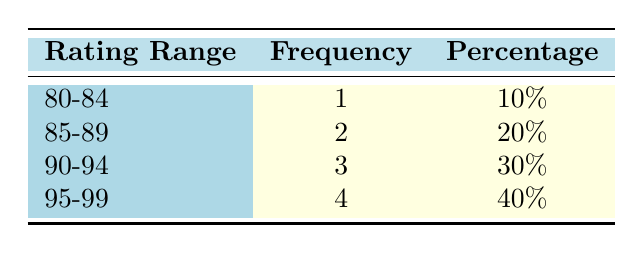What is the frequency of films with an audience rating between 90 and 94? The range of 90 to 94 appears in the table, where the frequency for this rating range is stated as 3.
Answer: 3 What percentage of films received an audience rating of 95 or above? To find this percentage, we look at the rating range of 95-99, which shows a frequency of 4 out of a total of 10 films. Therefore, the percentage is calculated as (4/10) * 100 = 40%.
Answer: 40% How many films have an audience rating lower than 85? According to the table, only the rating range of 80-84 has a frequency of 1, indicating that there is one film with a rating lower than 85.
Answer: 1 Is the statement "More than half of the films received audience ratings below 90" true or false? We check the ratings: 4 films have ratings of 89 or lower out of a total of 10 films, which is not more than half (5). Thus, the statement is false.
Answer: False What is the total number of films that have audience ratings of 90 and above? We add the frequencies of the rating ranges 90-94 (3) and 95-99 (4), giving a total of 3 + 4 = 7 films that have ratings of 90 and above.
Answer: 7 What is the average audience rating of films in the 95-99 range? The specific ratings in this range are 96, 97, 98, and 99. Calculating the average: (96 + 97 + 98 + 99) / 4 = 97.5.
Answer: 97.5 How many films are represented in the 85-89 rating range? According to the table, there are 2 films listed under the rating range of 85-89.
Answer: 2 Which rating range has the least number of films? The rating range of 80-84 has a frequency of 1, which is the lowest among all listed ranges.
Answer: 80-84 How many total films were assessed in this table? The total is determined by adding the frequencies of all rating ranges: (1 + 2 + 3 + 4) = 10 films total.
Answer: 10 